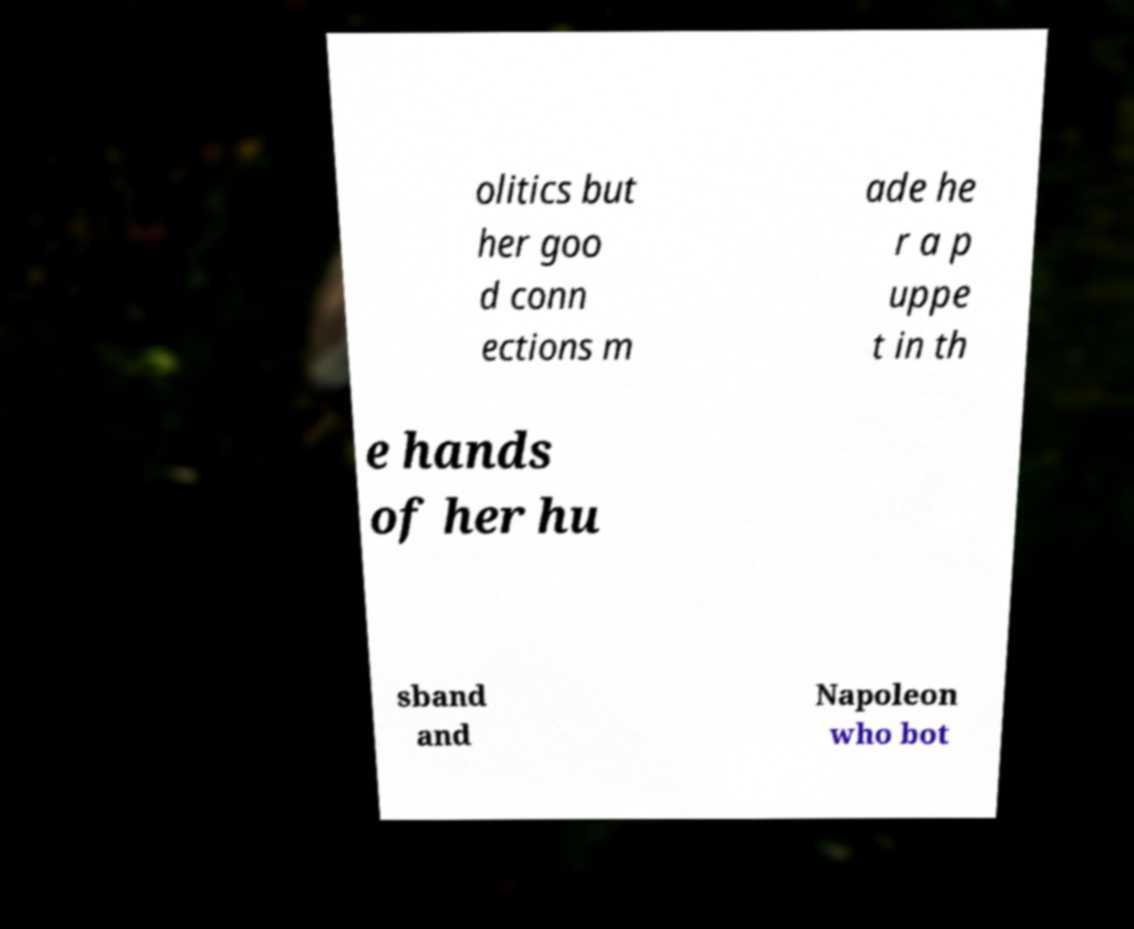For documentation purposes, I need the text within this image transcribed. Could you provide that? olitics but her goo d conn ections m ade he r a p uppe t in th e hands of her hu sband and Napoleon who bot 